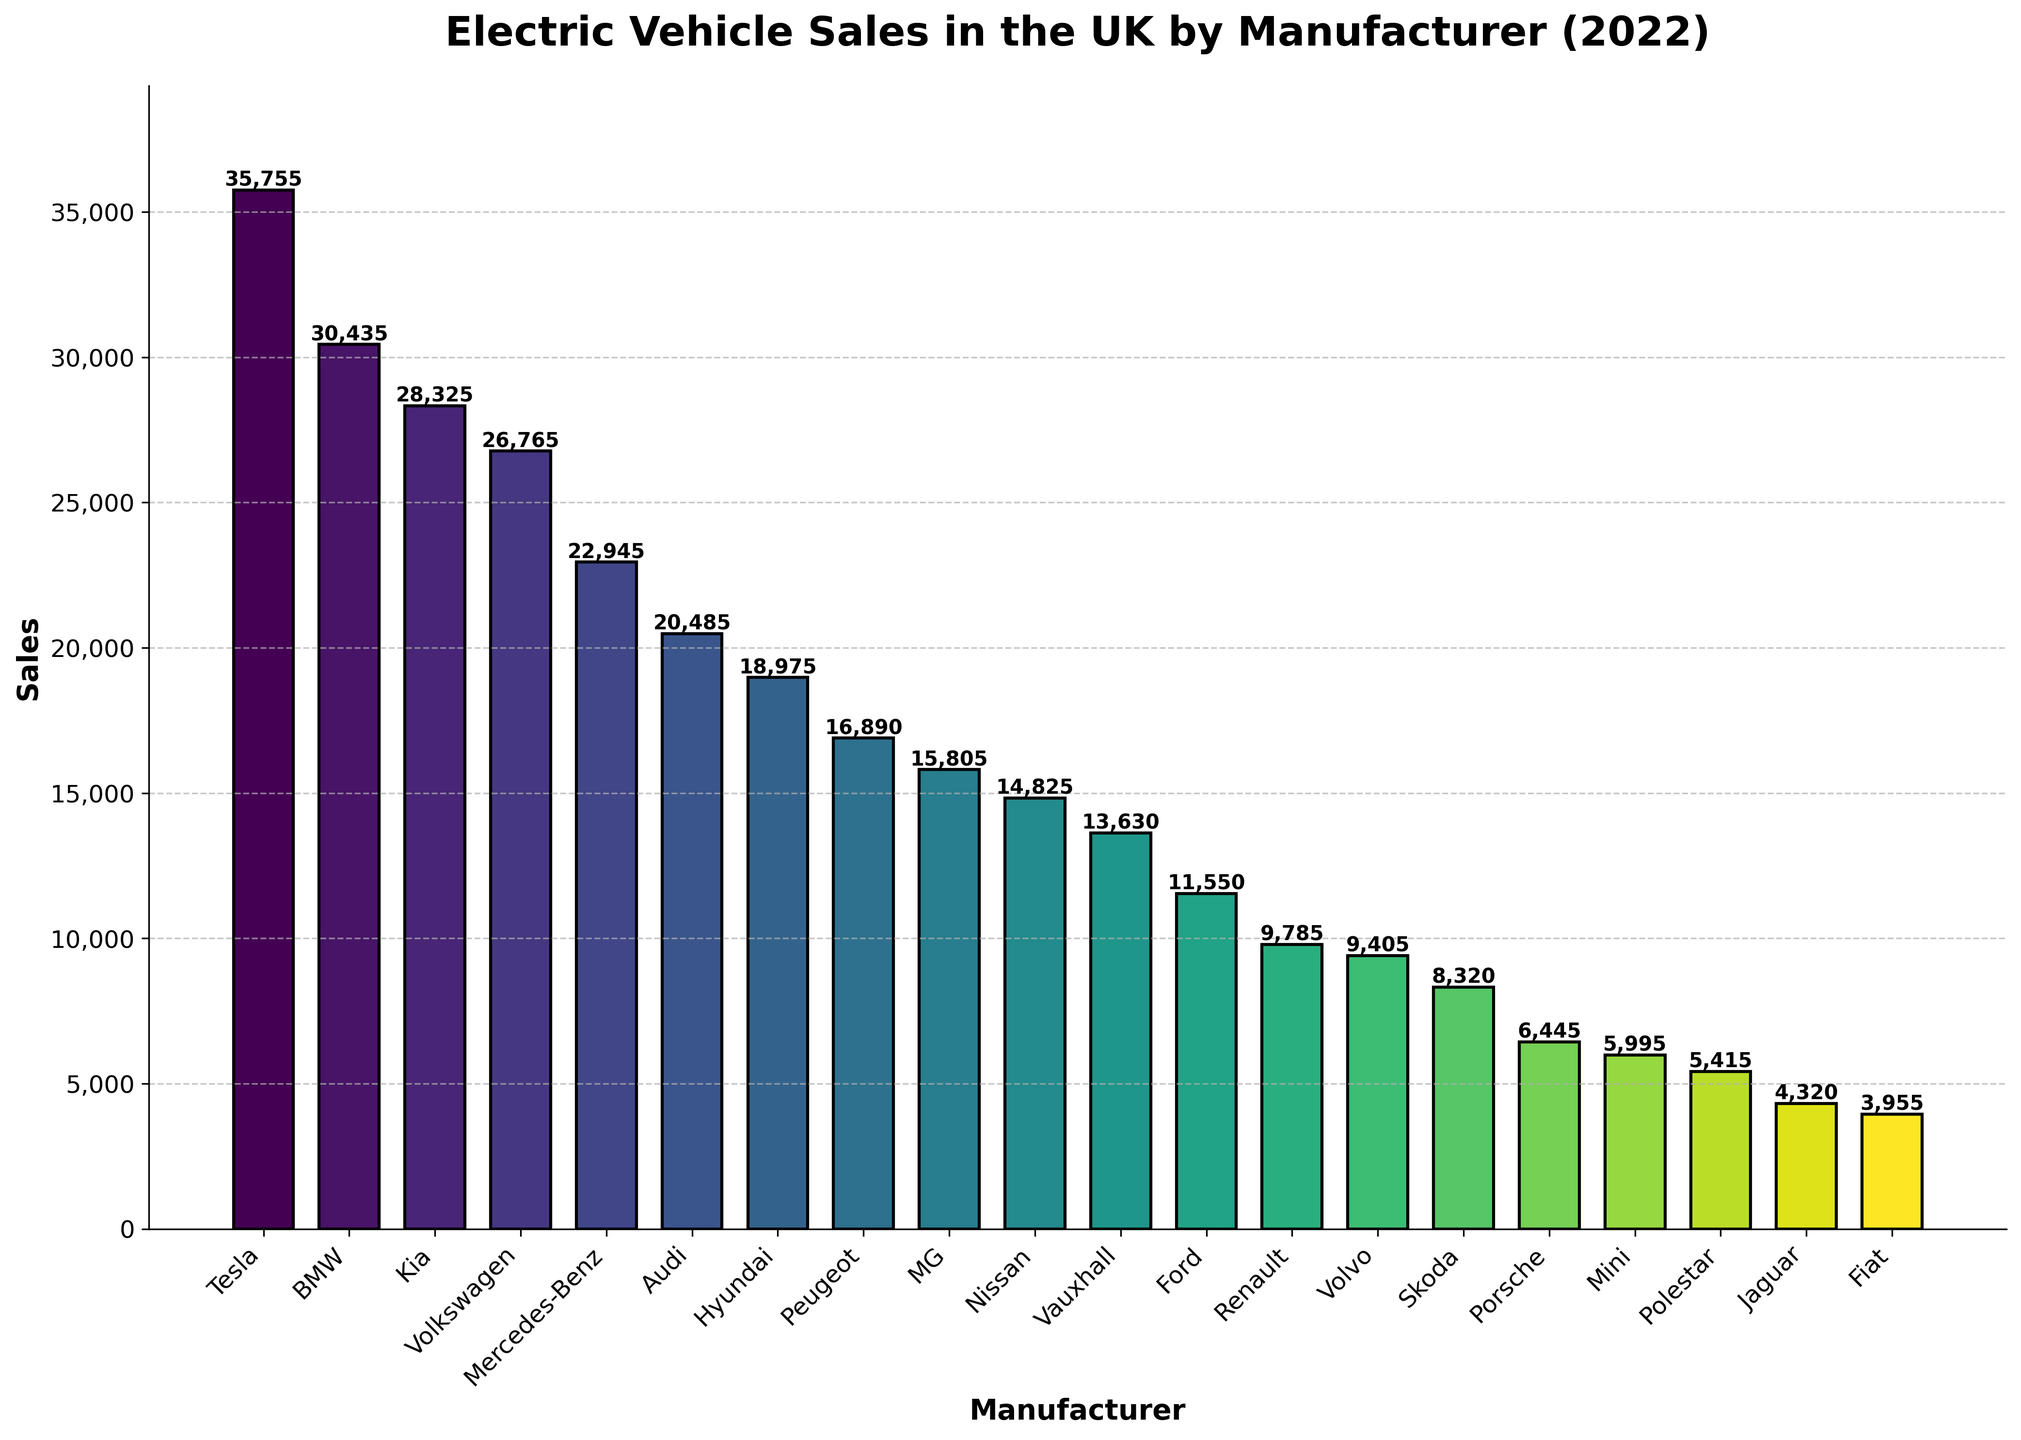Which manufacturer had the highest EV sales in the UK in 2022? The bar that has the greatest height represents the manufacturer with the highest sales. Tesla's bar is the tallest among all.
Answer: Tesla Which manufacturer's sales are less than 10,000 but more than 5,000? Look for bars that fall between the heights representing 5,000 and 10,000 sales. Volvo, Skoda, Porsche, Mini, and Polestar fit this criterion.
Answer: Volvo, Skoda, Porsche, Mini, Polestar What is the total EV sales of the top three manufacturers? Sum the heights (sales) of the bars for Tesla, BMW, and Kia. Tesla (35,755) + BMW (30,435) + Kia (28,325) = 94,515.
Answer: 94,515 How much more did Tesla sell compared to Hyundai? Subtract Hyundai's sales from Tesla's sales. Tesla (35,755) - Hyundai (18,975) = 16,780.
Answer: 16,780 Which manufacturer sold exactly half the amount of EVs as BMW? Calculate half of BMW's sales and see which manufacturer's bar height matches this value. Half of BMW's 30,435 is 15,217.5; approximations show MG sold close to this amount with 15,805.
Answer: MG What is the range of EV sales among all manufacturers? Subtract the smallest value from the largest value among all bars. The highest is Tesla (35,755) and the lowest is Fiat (3,955). 35,755 - 3,955 = 31,800.
Answer: 31,800 Which manufacturers' sales are immediately higher and lower than Vauxhall's? Identify Vauxhall's sales and find the adjacent bars in height. Vauxhall has 13,630 sales, immediately higher is Nissan (14,825) and immediately lower is Ford (11,550).
Answer: Nissan, Ford What is the median EV sales value among all manufacturers listed? Arrange the sales values in ascending order and find the middle value. With 20 manufacturers, the median is the average of the 10th and 11th values. These are 14,825 (Nissan) and 13,630 (Vauxhall). (14,825 + 13,630) / 2 = 14,227.5.
Answer: 14,227.5 Which manufacturers have sales visually represented as different shades of the same color? Look at the gradient of colors and identify bars with differing intensities but in the same color palette. The bars follow shades of green (viridis colormap).
Answer: All manufacturers have different shades within a gradient How many manufacturers had sales greater than 20,000 but less than 30,000? Count the bars that fall within the height range representing 20,000 to 30,000 sales. BMW (30,435), Kia (28,325), Volkswagen (26,765), and Mercedes-Benz (22,945) fulfill this condition. This gives us 4 manufacturers.
Answer: 4 